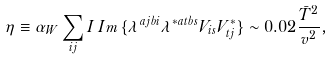Convert formula to latex. <formula><loc_0><loc_0><loc_500><loc_500>\eta \equiv \alpha _ { W } \sum _ { i j } I \, I m \, \{ \lambda ^ { a j b i } \lambda ^ { * a t b s } V _ { i s } V ^ { * } _ { t j } \} \sim 0 . 0 2 \frac { \bar { T } ^ { 2 } } { v ^ { 2 } } ,</formula> 